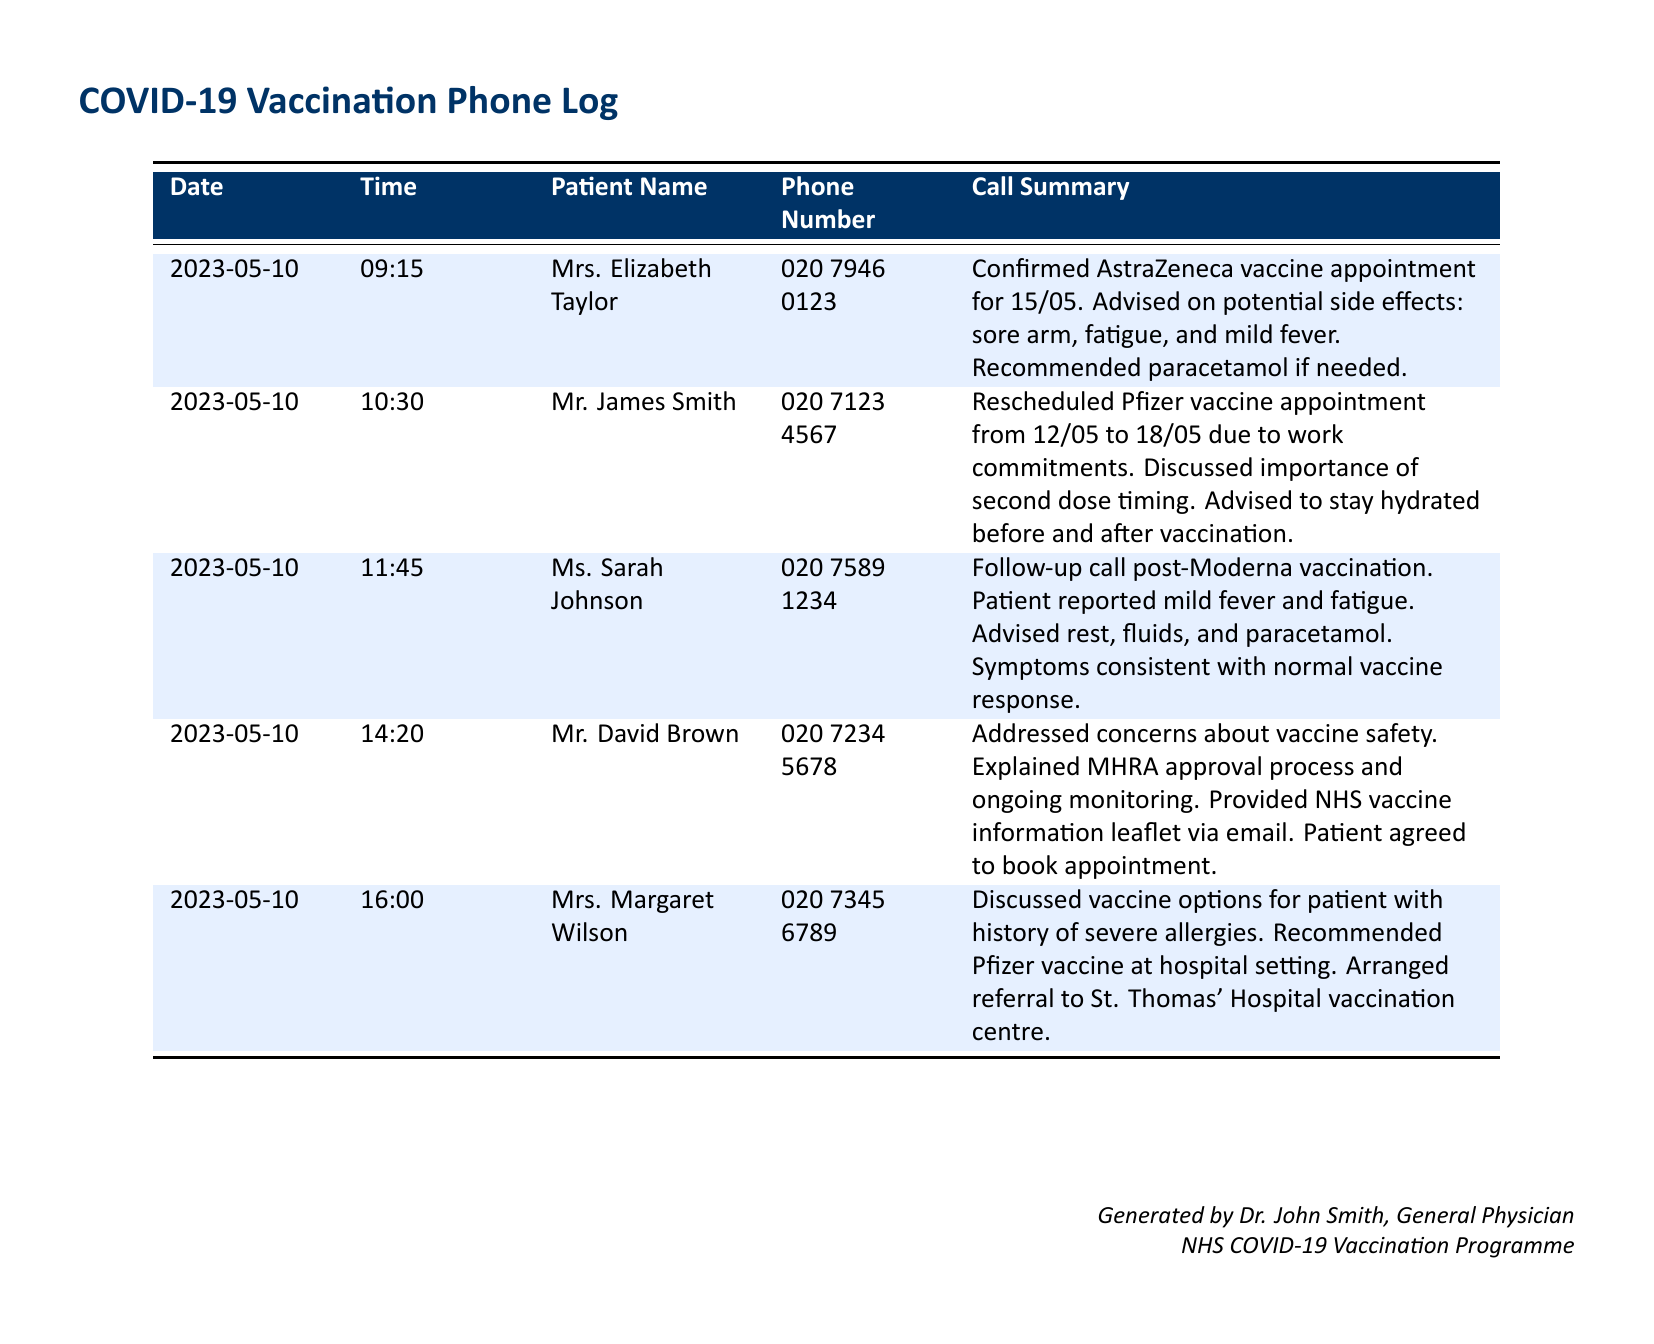What date is Mrs. Elizabeth Taylor's vaccine appointment? The appointment date for Mrs. Elizabeth Taylor is explicitly mentioned in her call summary, which states "Confirmed AstraZeneca vaccine appointment for 15/05."
Answer: 15/05 What vaccine did Mr. James Smith reschedule? The call summary for Mr. James Smith specifies that he rescheduled his Pfizer vaccine appointment.
Answer: Pfizer What symptoms did Ms. Sarah Johnson report after her vaccination? Ms. Sarah Johnson's call summary details that she reported mild fever and fatigue, which are symptoms typical after vaccination.
Answer: Mild fever and fatigue How many calls are logged on 2023-05-10? The document indicates there are five separate entries, each representing a distinct call on that date.
Answer: 5 Which patient was referred to St. Thomas' Hospital vaccination centre? The call summary for Mrs. Margaret Wilson mentions that she was arranged for a referral to the St. Thomas' Hospital vaccination centre.
Answer: Mrs. Margaret Wilson What was the main concern addressed in Mr. David Brown's call? Mr. David Brown's call summary indicates that he had concerns about vaccine safety, which were addressed during the conversation.
Answer: Vaccine safety What advice was given to address side effects for the Moderna vaccine? Ms. Sarah Johnson was advised to rest, drink fluids, and take paracetamol for her vaccine side effects.
Answer: Rest, fluids, and paracetamol What is the general theme of the conversations in the log? The conversations primarily revolve around COVID-19 vaccination appointments and their associated side effects.
Answer: Vaccination appointments and side effects What type of vaccine did Mrs. Elizabeth Taylor confirm? The document states that she confirmed the AstraZeneca vaccine for her appointment.
Answer: AstraZeneca 